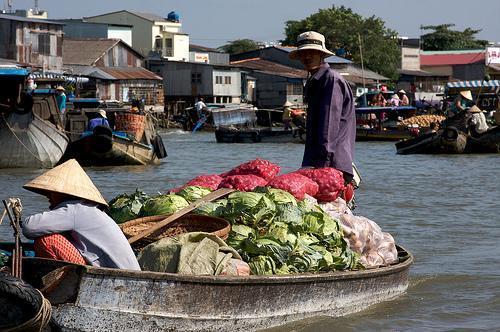How many people are in the boat?
Give a very brief answer. 2. 